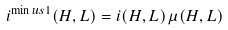<formula> <loc_0><loc_0><loc_500><loc_500>i ^ { \min u s 1 } ( H , L ) = i ( H , L ) \, \mu ( H , L )</formula> 